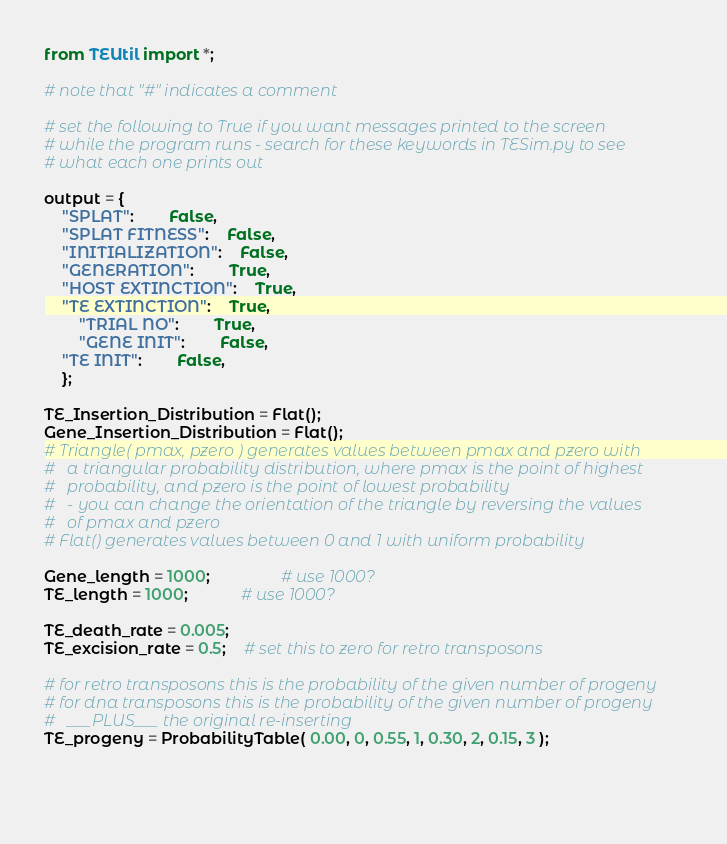Convert code to text. <code><loc_0><loc_0><loc_500><loc_500><_Python_>from TEUtil import *;

# note that "#" indicates a comment

# set the following to True if you want messages printed to the screen
# while the program runs - search for these keywords in TESim.py to see
# what each one prints out

output = {
	"SPLAT":		False,
	"SPLAT FITNESS":	False,
	"INITIALIZATION":	False,
	"GENERATION":		True,
	"HOST EXTINCTION":	True,
	"TE EXTINCTION":	True,
        "TRIAL NO":		True,
        "GENE INIT":		False,
	"TE INIT":		False,
	};

TE_Insertion_Distribution = Flat();
Gene_Insertion_Distribution = Flat();
# Triangle( pmax, pzero ) generates values between pmax and pzero with 
#   a triangular probability distribution, where pmax is the point of highest
#   probability, and pzero is the point of lowest probability
#   - you can change the orientation of the triangle by reversing the values
#   of pmax and pzero
# Flat() generates values between 0 and 1 with uniform probability

Gene_length = 1000;		        # use 1000?
TE_length = 1000;			# use 1000?

TE_death_rate = 0.005;
TE_excision_rate = 0.5;	# set this to zero for retro transposons

# for retro transposons this is the probability of the given number of progeny
# for dna transposons this is the probability of the given number of progeny
#   ___PLUS___ the original re-inserting
TE_progeny = ProbabilityTable( 0.00, 0, 0.55, 1, 0.30, 2, 0.15, 3 );


						 </code> 